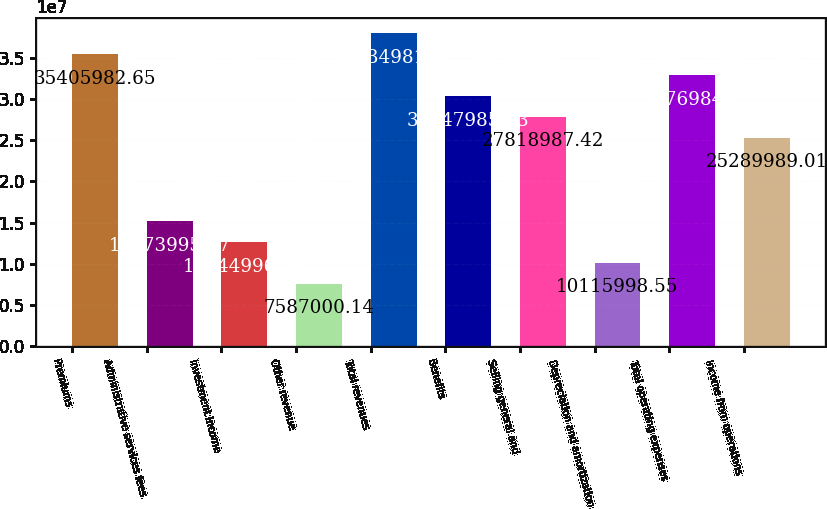Convert chart. <chart><loc_0><loc_0><loc_500><loc_500><bar_chart><fcel>Premiums<fcel>Administrative services fees<fcel>Investment income<fcel>Other revenue<fcel>Total revenues<fcel>Benefits<fcel>Selling general and<fcel>Depreciation and amortization<fcel>Total operating expenses<fcel>Income from operations<nl><fcel>3.5406e+07<fcel>1.5174e+07<fcel>1.2645e+07<fcel>7.587e+06<fcel>3.7935e+07<fcel>3.0348e+07<fcel>2.7819e+07<fcel>1.0116e+07<fcel>3.2877e+07<fcel>2.529e+07<nl></chart> 